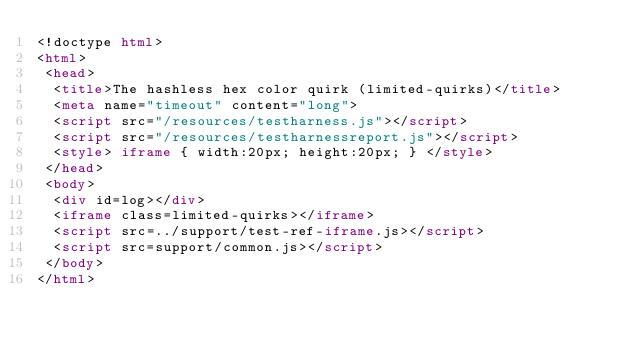Convert code to text. <code><loc_0><loc_0><loc_500><loc_500><_HTML_><!doctype html>
<html>
 <head>
  <title>The hashless hex color quirk (limited-quirks)</title>
  <meta name="timeout" content="long">
  <script src="/resources/testharness.js"></script>
  <script src="/resources/testharnessreport.js"></script>
  <style> iframe { width:20px; height:20px; } </style>
 </head>
 <body>
  <div id=log></div>
  <iframe class=limited-quirks></iframe>
  <script src=../support/test-ref-iframe.js></script>
  <script src=support/common.js></script>
 </body>
</html>
</code> 